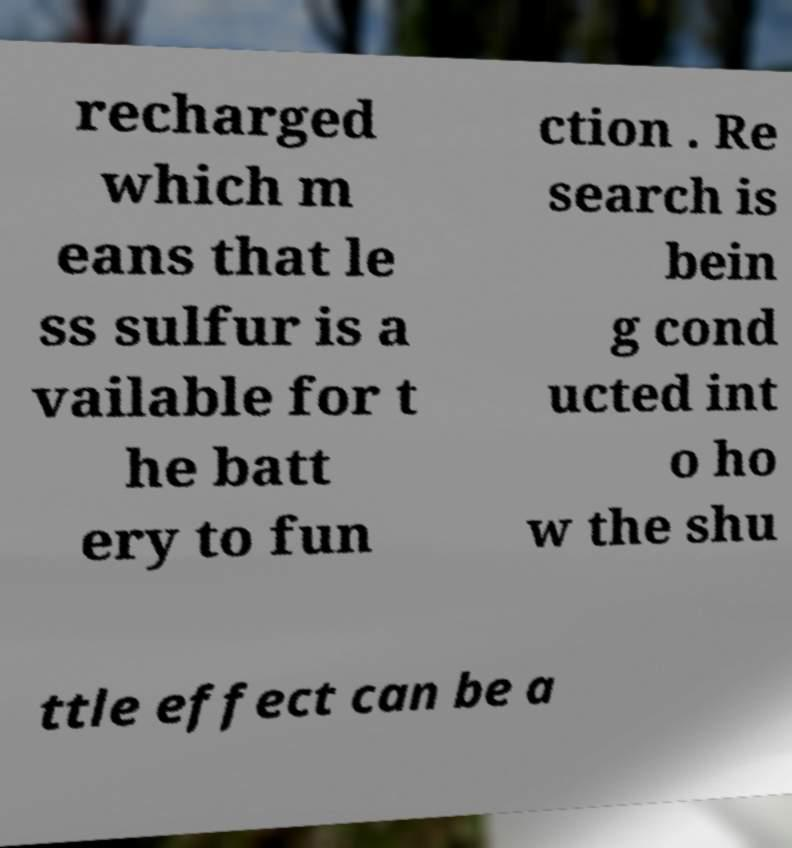There's text embedded in this image that I need extracted. Can you transcribe it verbatim? recharged which m eans that le ss sulfur is a vailable for t he batt ery to fun ction . Re search is bein g cond ucted int o ho w the shu ttle effect can be a 